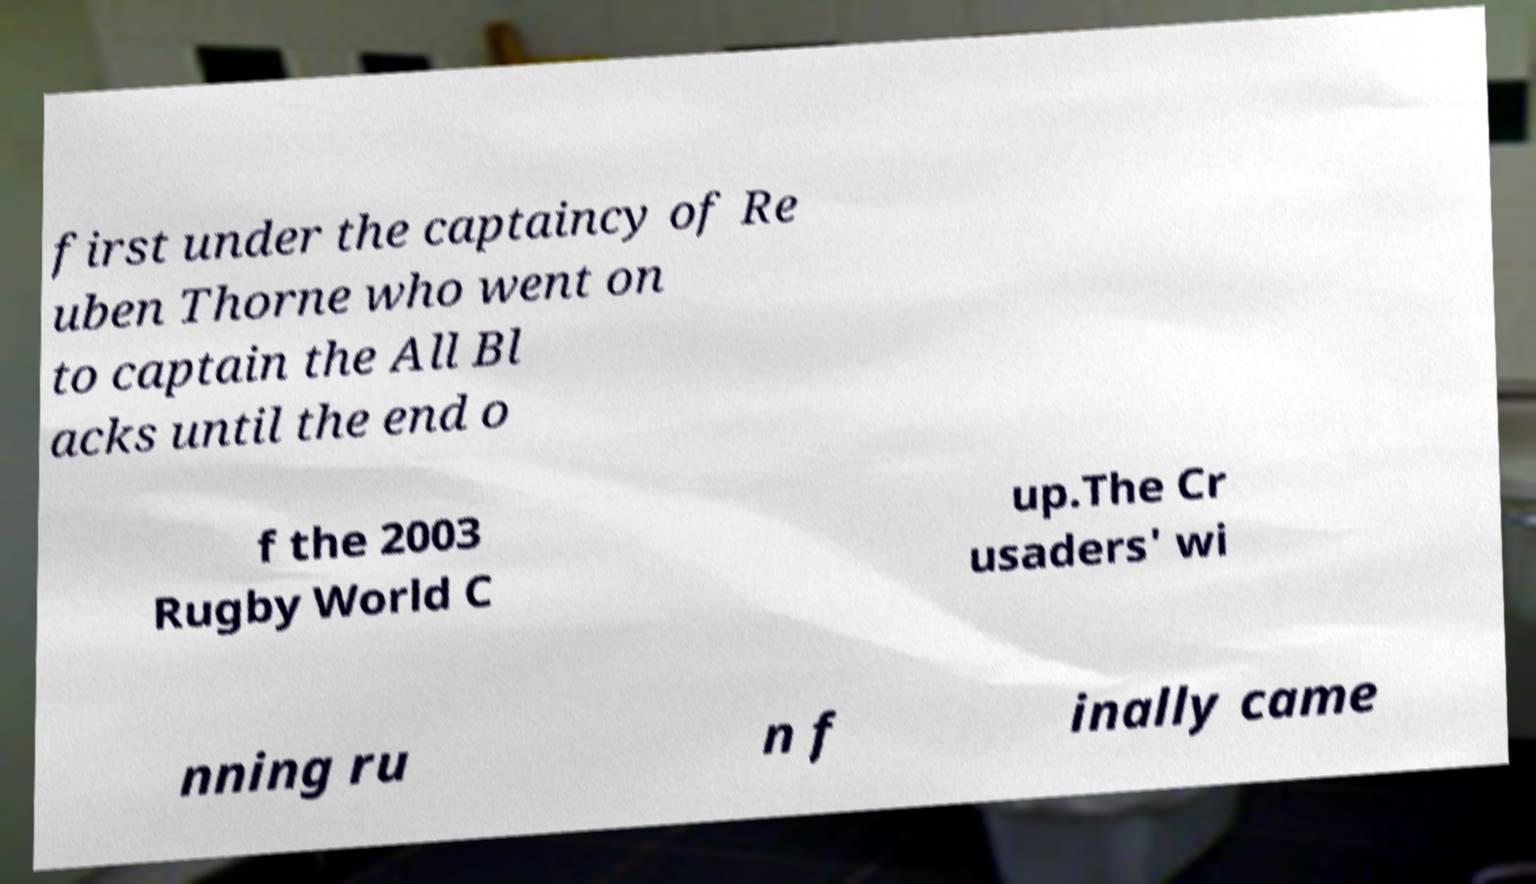Could you assist in decoding the text presented in this image and type it out clearly? first under the captaincy of Re uben Thorne who went on to captain the All Bl acks until the end o f the 2003 Rugby World C up.The Cr usaders' wi nning ru n f inally came 